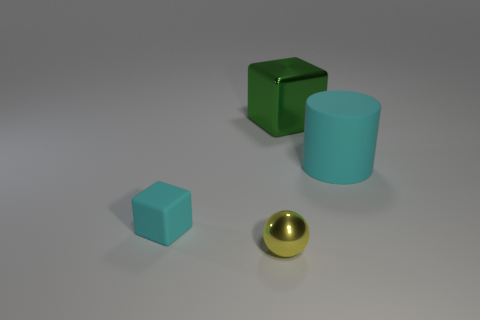Add 4 large yellow shiny blocks. How many objects exist? 8 Subtract all cylinders. How many objects are left? 3 Add 3 green things. How many green things exist? 4 Subtract 0 purple blocks. How many objects are left? 4 Subtract all blocks. Subtract all metal blocks. How many objects are left? 1 Add 3 rubber objects. How many rubber objects are left? 5 